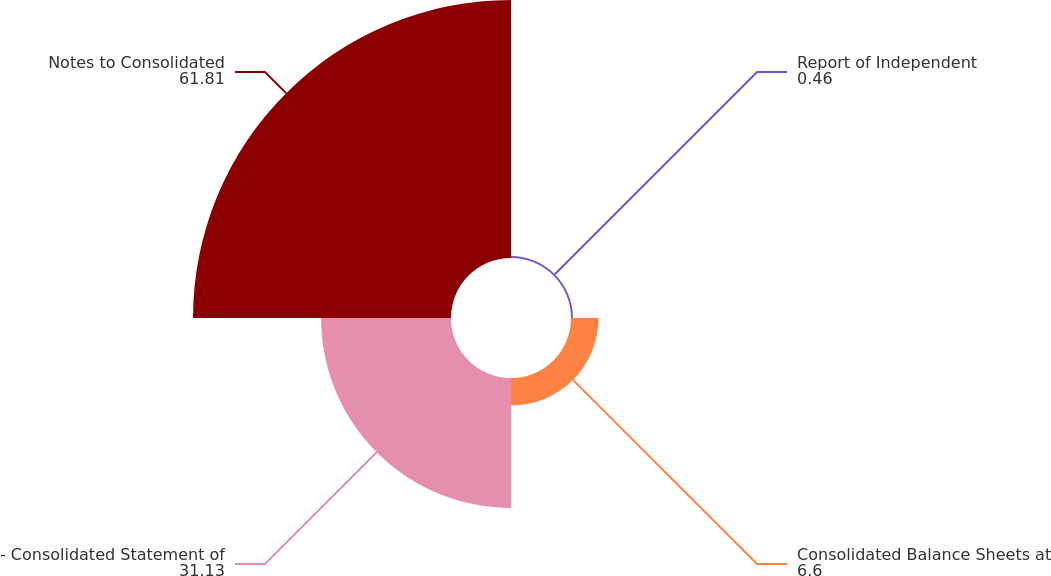Convert chart to OTSL. <chart><loc_0><loc_0><loc_500><loc_500><pie_chart><fcel>Report of Independent<fcel>Consolidated Balance Sheets at<fcel>- Consolidated Statement of<fcel>Notes to Consolidated<nl><fcel>0.46%<fcel>6.6%<fcel>31.13%<fcel>61.81%<nl></chart> 